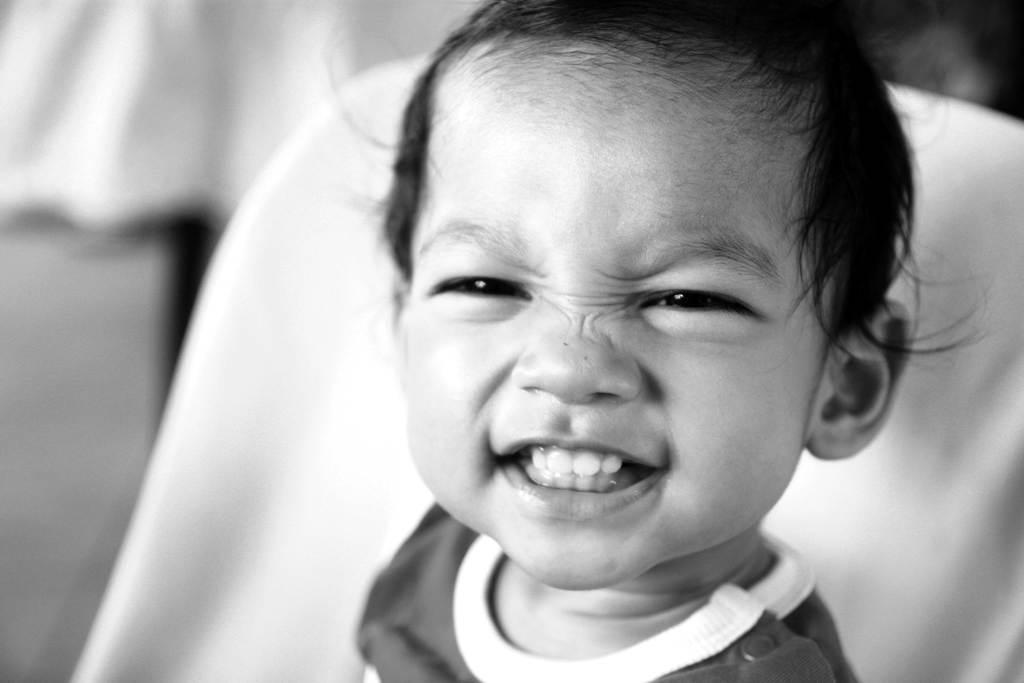What is the color scheme of the image? The image is in black and white. Who or what is the main subject in the image? There is a child in the image. What is the child doing in the image? The child is sitting on a chair. Can you describe the background of the image? The background of the image is blurred. Is there a potato being used as a toy by the child in the image? There is no potato present in the image, and the child is not using any toy. 